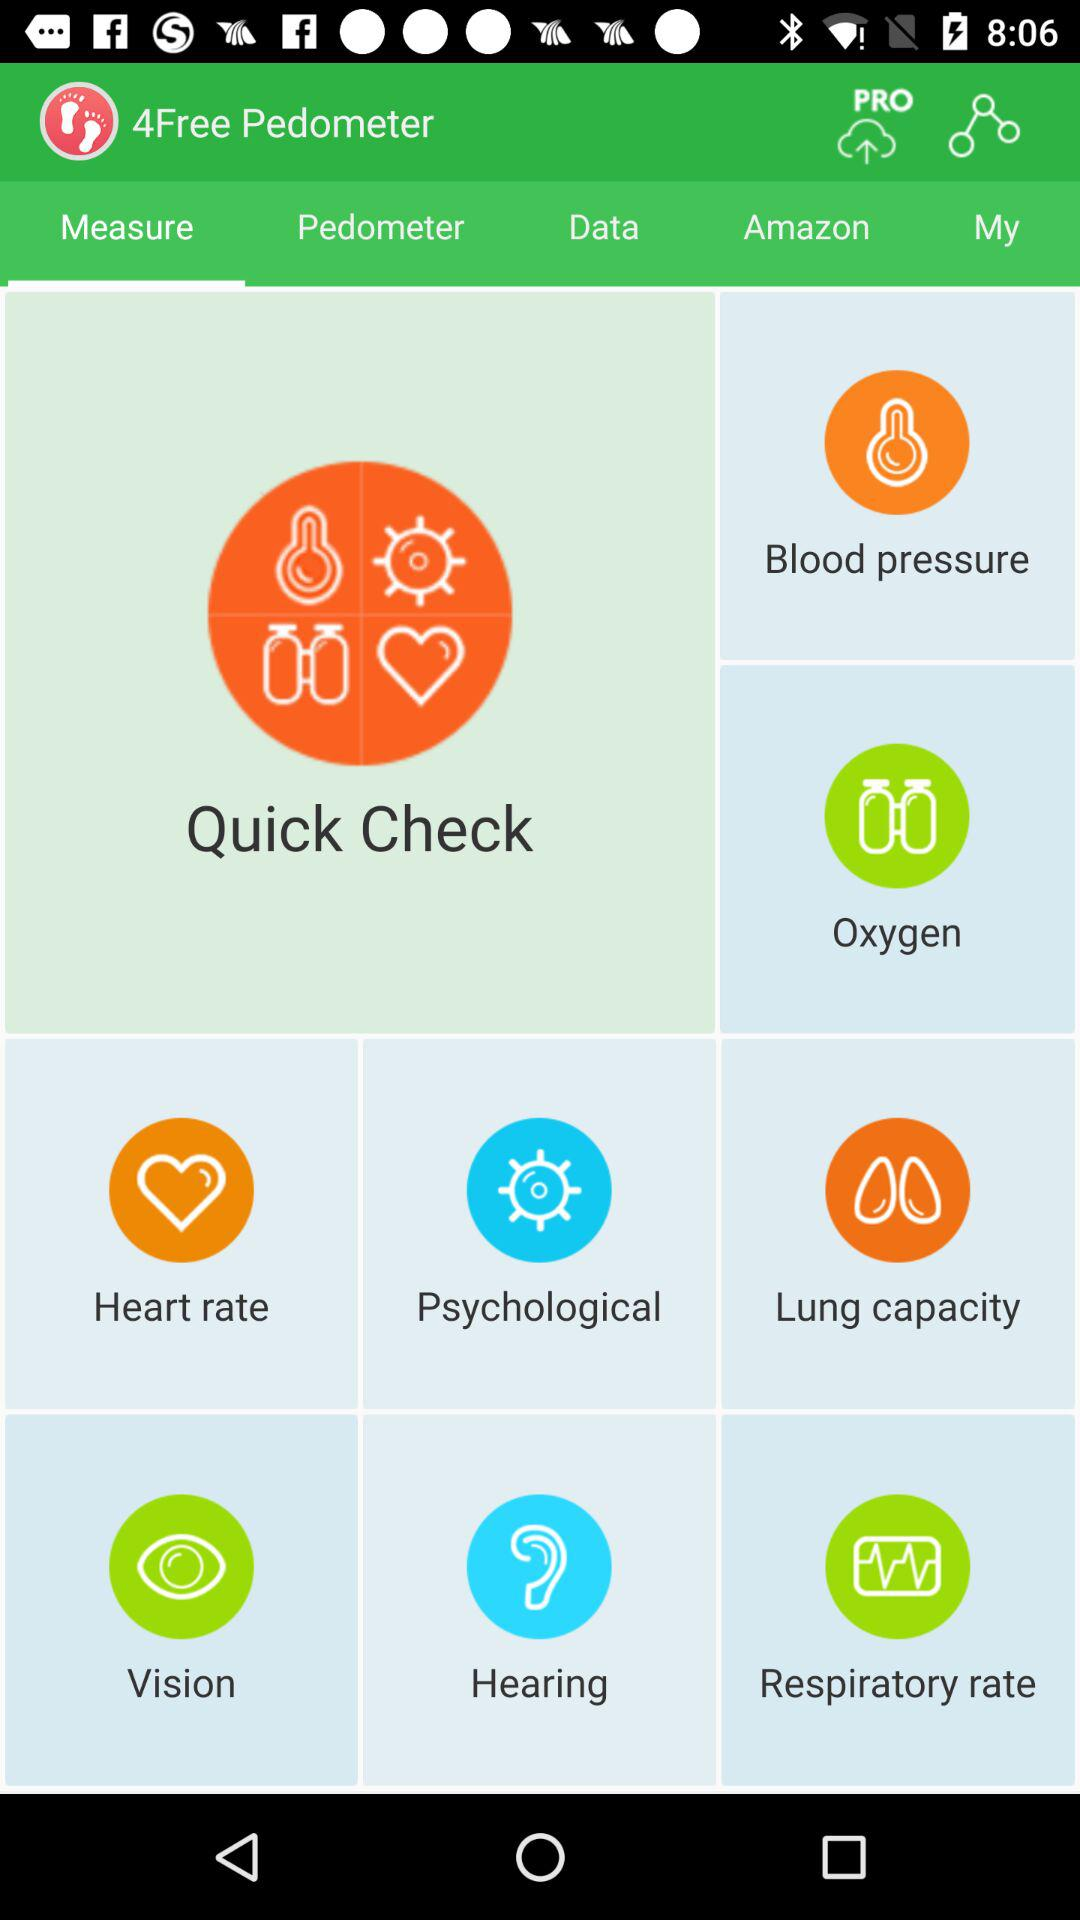What tab is selected? The selected tab is "Measure". 